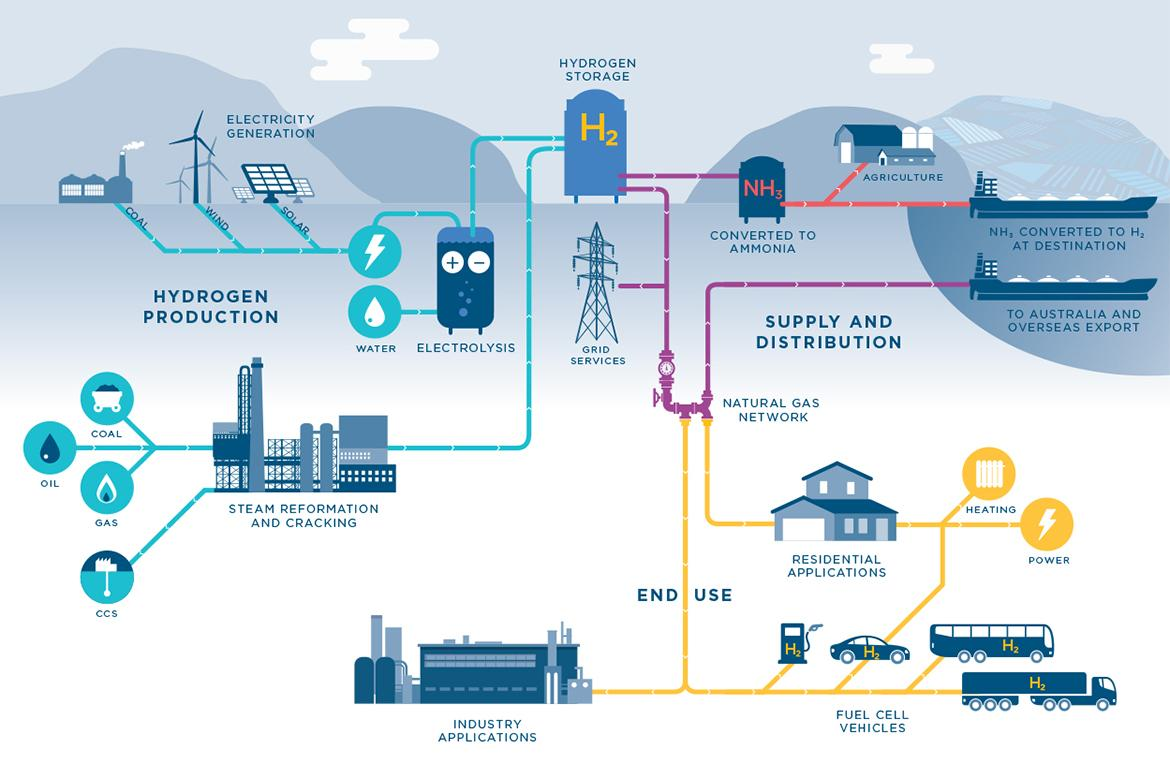Specify some key components in this picture. The use of coal, wind, and solar energy is commonly employed for hydrogen production. Ammonia is a compound composed of nitrogen and hydrogen atoms with the chemical formula NH3. Hydrogen gas is required for heating a residence. Hydrogen is used in agriculture in the form of ammonia, which is a crucial fertilizer for crop growth. 